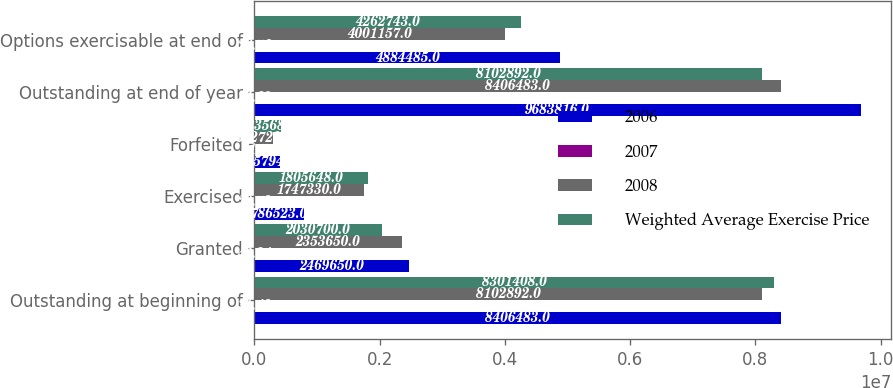<chart> <loc_0><loc_0><loc_500><loc_500><stacked_bar_chart><ecel><fcel>Outstanding at beginning of<fcel>Granted<fcel>Exercised<fcel>Forfeited<fcel>Outstanding at end of year<fcel>Options exercisable at end of<nl><fcel>2006<fcel>8.40648e+06<fcel>2.46965e+06<fcel>786523<fcel>405794<fcel>9.68382e+06<fcel>4.88448e+06<nl><fcel>2007<fcel>31.43<fcel>42.34<fcel>20.72<fcel>41.7<fcel>34.69<fcel>26.76<nl><fcel>2008<fcel>8.10289e+06<fcel>2.35365e+06<fcel>1.74733e+06<fcel>302729<fcel>8.40648e+06<fcel>4.00116e+06<nl><fcel>Weighted Average Exercise Price<fcel>8.30141e+06<fcel>2.0307e+06<fcel>1.80565e+06<fcel>423568<fcel>8.10289e+06<fcel>4.26274e+06<nl></chart> 